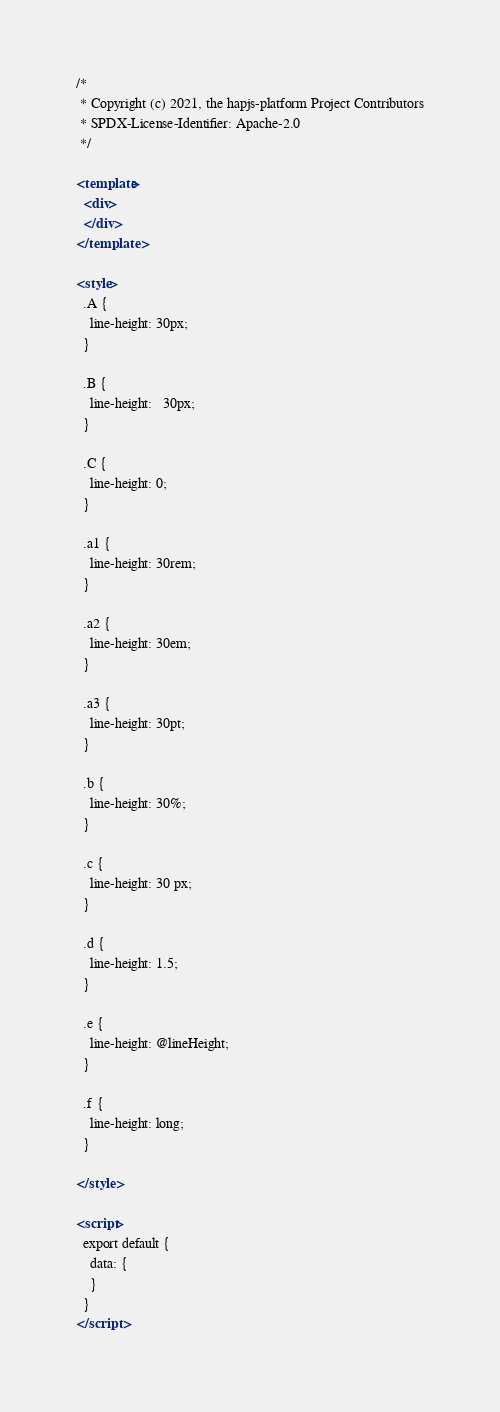Convert code to text. <code><loc_0><loc_0><loc_500><loc_500><_XML_>/*
 * Copyright (c) 2021, the hapjs-platform Project Contributors
 * SPDX-License-Identifier: Apache-2.0
 */

<template>
  <div>
  </div>
</template>

<style>
  .A {
    line-height: 30px;
  }

  .B {
    line-height:   30px;
  }

  .C {
    line-height: 0;
  }

  .a1 {
    line-height: 30rem;
  }

  .a2 {
    line-height: 30em;
  }

  .a3 {
    line-height: 30pt;
  }

  .b {
    line-height: 30%;
  }

  .c {
    line-height: 30 px;
  }

  .d {
    line-height: 1.5;
  }

  .e {
    line-height: @lineHeight;
  }

  .f {
    line-height: long;
  }

</style>

<script>
  export default {
    data: {
    }
  }
</script></code> 